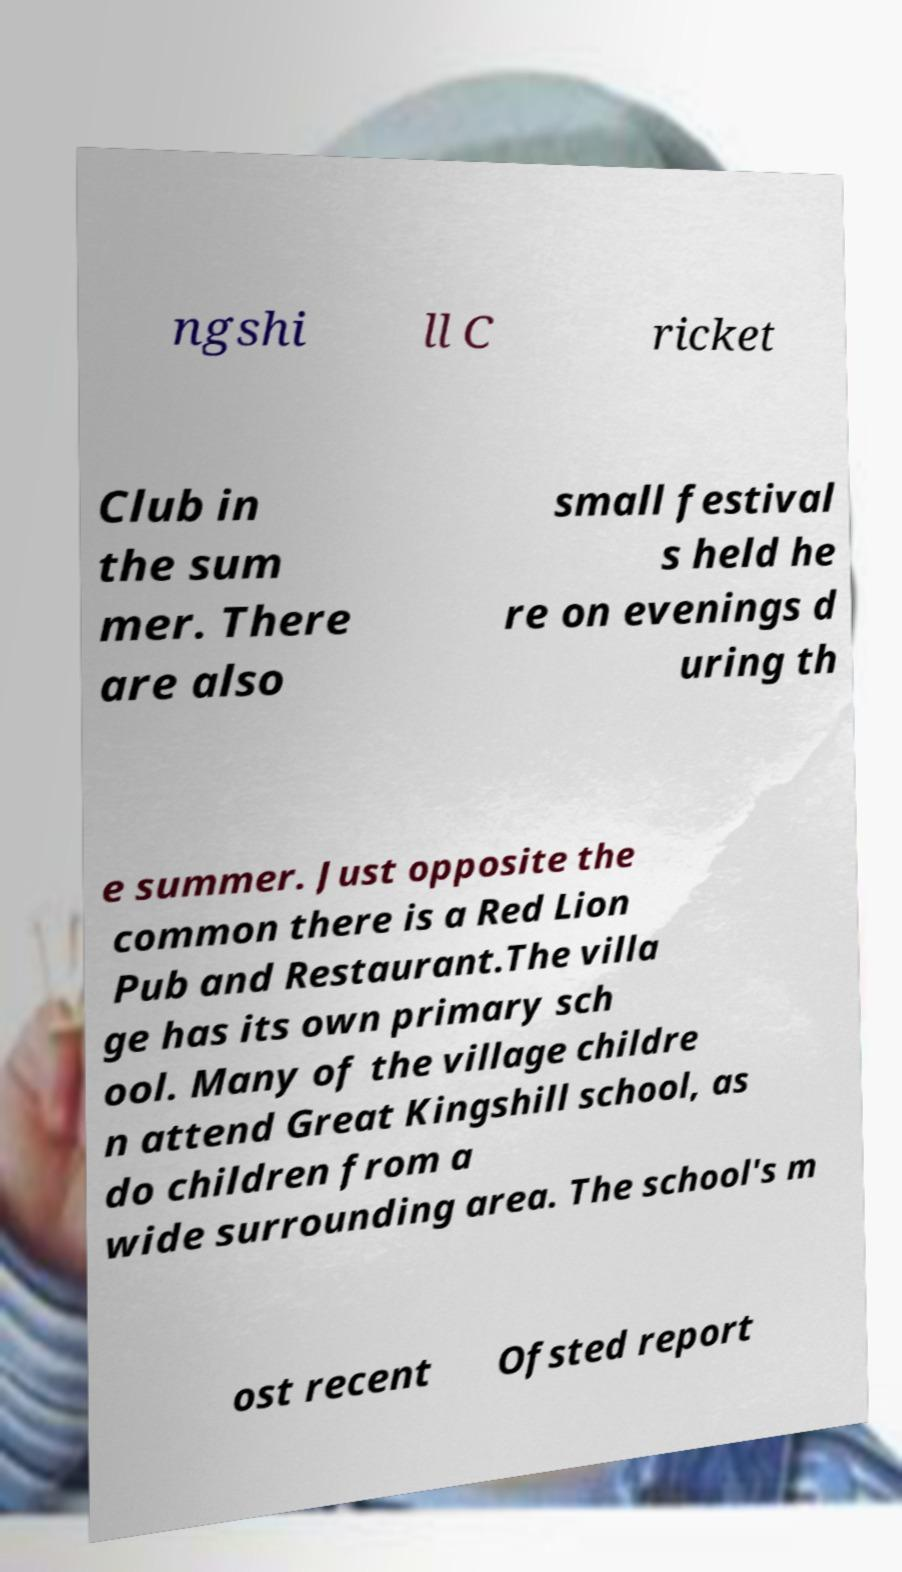There's text embedded in this image that I need extracted. Can you transcribe it verbatim? ngshi ll C ricket Club in the sum mer. There are also small festival s held he re on evenings d uring th e summer. Just opposite the common there is a Red Lion Pub and Restaurant.The villa ge has its own primary sch ool. Many of the village childre n attend Great Kingshill school, as do children from a wide surrounding area. The school's m ost recent Ofsted report 